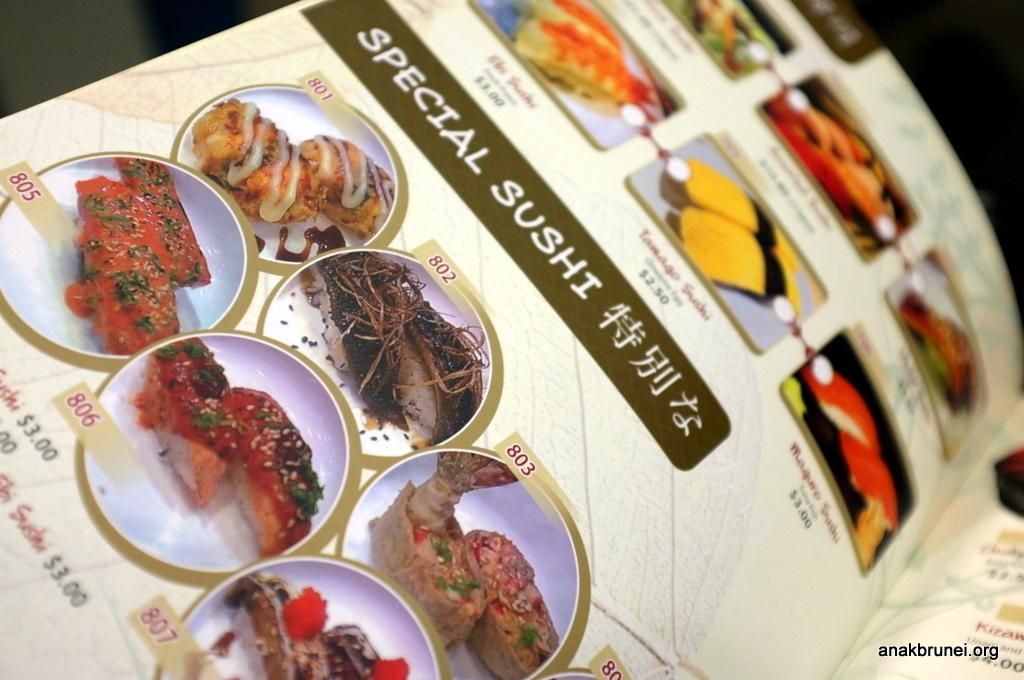What is the main subject of the image? The main subject of the image is a page of a book. What can be found on the page of the book? The page contains different food items. How would you describe the overall color scheme of the image? The background of the image is dark, and the book is in cream color. How many tails can be seen on the cats in the image? There are no cats present in the image, so there are no tails to count. What type of sail is visible in the image? There is no sail present in the image. 